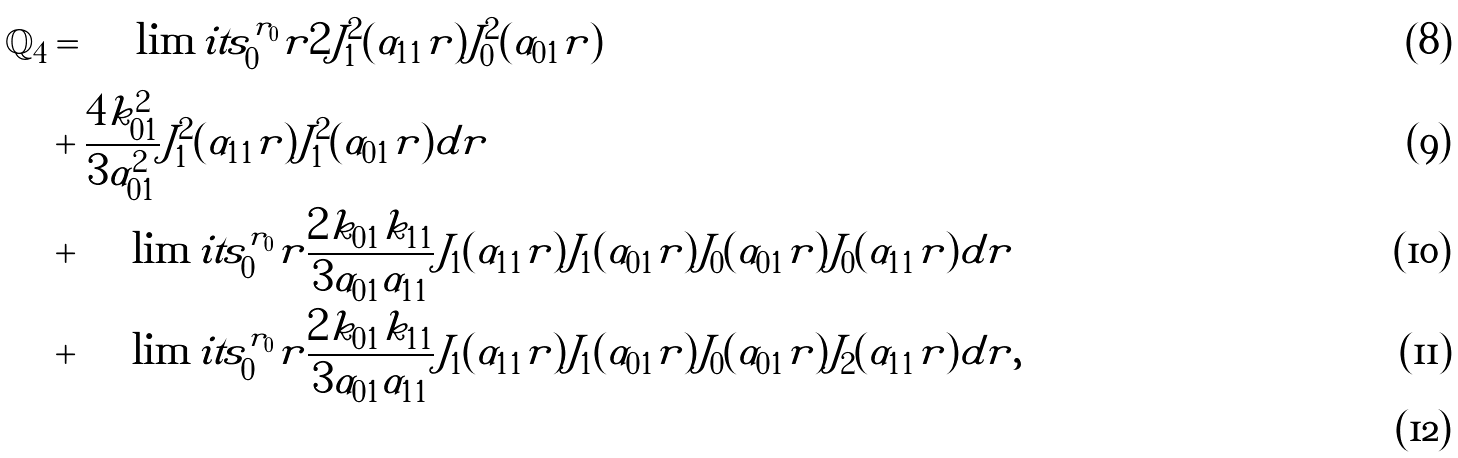<formula> <loc_0><loc_0><loc_500><loc_500>\mathbb { Q } _ { 4 } & = \int \lim i t s _ { 0 } ^ { r _ { 0 } } r 2 J _ { 1 } ^ { 2 } ( \alpha _ { 1 1 } r ) J _ { 0 } ^ { 2 } ( \alpha _ { 0 1 } r ) \\ & + \frac { 4 k _ { 0 1 } ^ { 2 } } { 3 \alpha _ { 0 1 } ^ { 2 } } J _ { 1 } ^ { 2 } ( \alpha _ { 1 1 } r ) J _ { 1 } ^ { 2 } ( \alpha _ { 0 1 } r ) d r \\ & + \int \lim i t s _ { 0 } ^ { r _ { 0 } } r \frac { 2 k _ { 0 1 } k _ { 1 1 } } { 3 \alpha _ { 0 1 } \alpha _ { 1 1 } } J _ { 1 } ( \alpha _ { 1 1 } r ) J _ { 1 } ( \alpha _ { 0 1 } r ) J _ { 0 } ( \alpha _ { 0 1 } r ) J _ { 0 } ( \alpha _ { 1 1 } r ) d r \\ & + \int \lim i t s _ { 0 } ^ { r _ { 0 } } r \frac { 2 k _ { 0 1 } k _ { 1 1 } } { 3 \alpha _ { 0 1 } \alpha _ { 1 1 } } J _ { 1 } ( \alpha _ { 1 1 } r ) J _ { 1 } ( \alpha _ { 0 1 } r ) J _ { 0 } ( \alpha _ { 0 1 } r ) J _ { 2 } ( \alpha _ { 1 1 } r ) d r , \\</formula> 